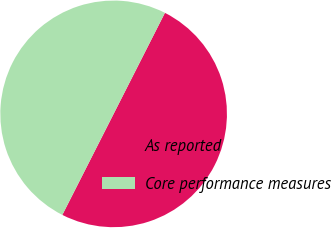<chart> <loc_0><loc_0><loc_500><loc_500><pie_chart><fcel>As reported<fcel>Core performance measures<nl><fcel>50.0%<fcel>50.0%<nl></chart> 